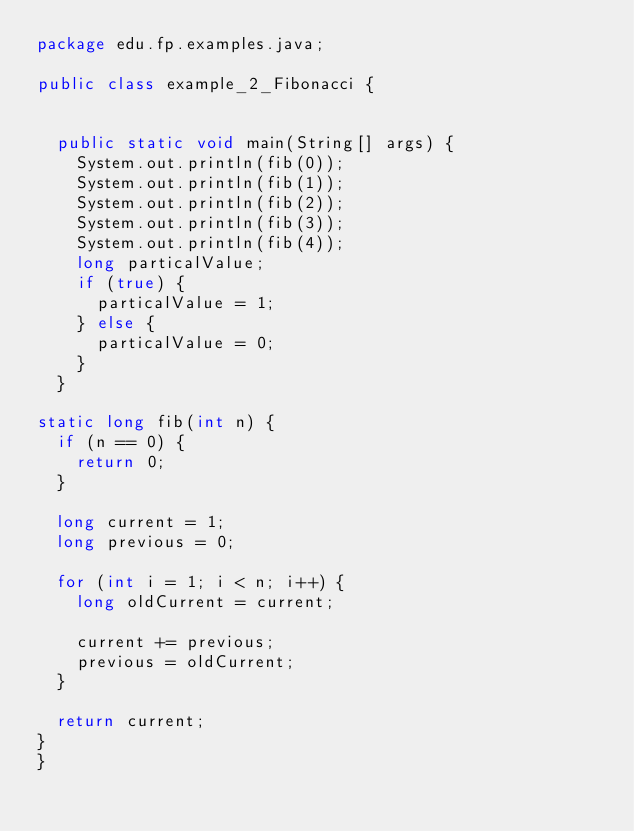<code> <loc_0><loc_0><loc_500><loc_500><_Java_>package edu.fp.examples.java;

public class example_2_Fibonacci {


  public static void main(String[] args) {
    System.out.println(fib(0));
    System.out.println(fib(1));
    System.out.println(fib(2));
    System.out.println(fib(3));
    System.out.println(fib(4));
    long particalValue;
    if (true) {
      particalValue = 1;
    } else {
      particalValue = 0;
    }
  }

static long fib(int n) {
  if (n == 0) {
    return 0;
  }

  long current = 1;
  long previous = 0;

  for (int i = 1; i < n; i++) {
    long oldCurrent = current;

    current += previous;
    previous = oldCurrent;
  }

  return current;
}
}
</code> 